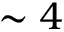Convert formula to latex. <formula><loc_0><loc_0><loc_500><loc_500>\sim 4</formula> 